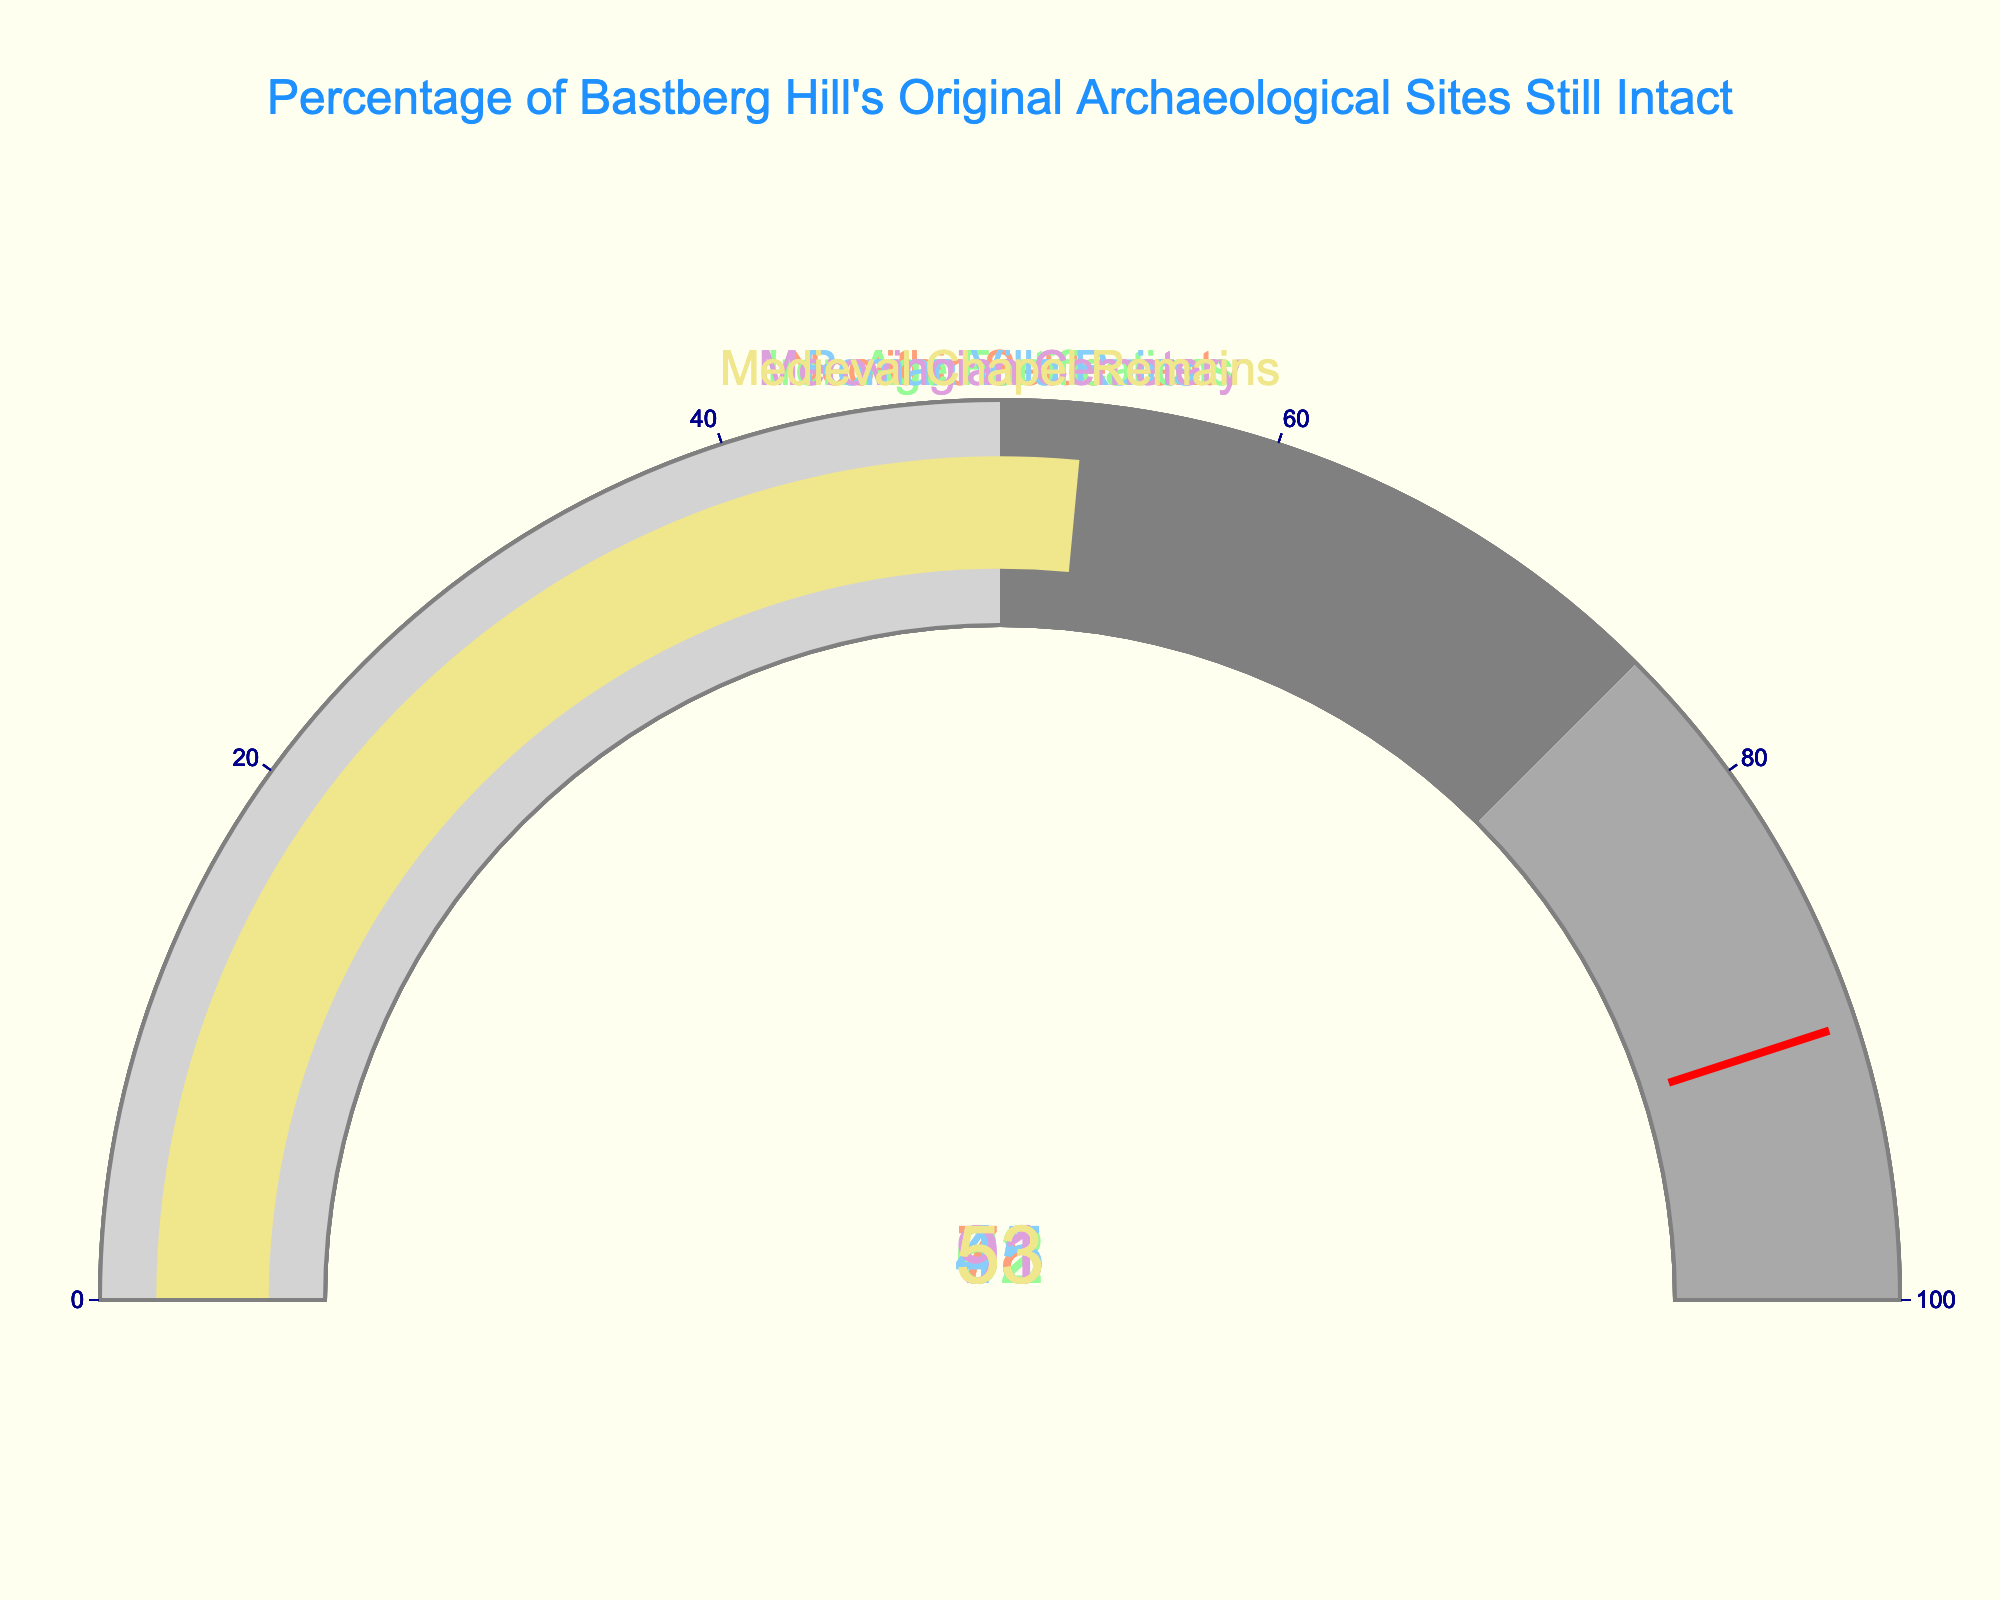What is the title of the figure? The title is located at the top of the figure and is meant to describe the overall theme or purpose of the data being displayed. Here, the title is "Percentage of Bastberg Hill's Original Archaeological Sites Still Intact".
Answer: Percentage of Bastberg Hill's Original Archaeological Sites Still Intact How many distinct archaeological sites are evaluated in the figure? To answer this, count the number of gauges, each representing a distinct archaeological site. There are five gauges, indicating five distinct sites.
Answer: Five Which archaeological site has the highest percentage of intactness? Look at the values displayed within each gauge. The Merovingian Cemetery gauge shows the highest value at 91%.
Answer: Merovingian Cemetery What is the percentage of intactness for the Roman Villa Ruins? Refer to the gauge labeled “Roman Villa Ruins” and find the number displayed. The percentage shown is 45%.
Answer: 45% What is the difference in the percentage of intactness between the Neolithic Settlement and Iron Age Fortifications? Subtract the percentage of the Iron Age Fortifications (62%) from the percentage of the Neolithic Settlement (78%) to find the difference: 78% - 62% = 16%.
Answer: 16% Which site has an intactness percentage closest to 50%? Compare the displayed percentages and find the closest to 50%. The Medieval Chapel Remains show a value of 53%, which is closest to 50%.
Answer: Medieval Chapel Remains Are there any sites with an intactness percentage below 50%? Scan the listed percentages to check if any are below 50%. The Roman Villa Ruins at 45% is the only one below 50%.
Answer: Yes, Roman Villa Ruins What is the average percentage of intactness across all the sites? First, add all percentages: 78% + 62% + 45% + 91% + 53% = 329%, then divide by the number of sites (5): 329% / 5 = 65.8%.
Answer: 65.8% Which site exceeds the threshold value of 90% intactness? Look at the gauges and identify any with values over the threshold of 90%. The Merovingian Cemetery has a percentage of 91%, which exceeds the threshold.
Answer: Merovingian Cemetery 